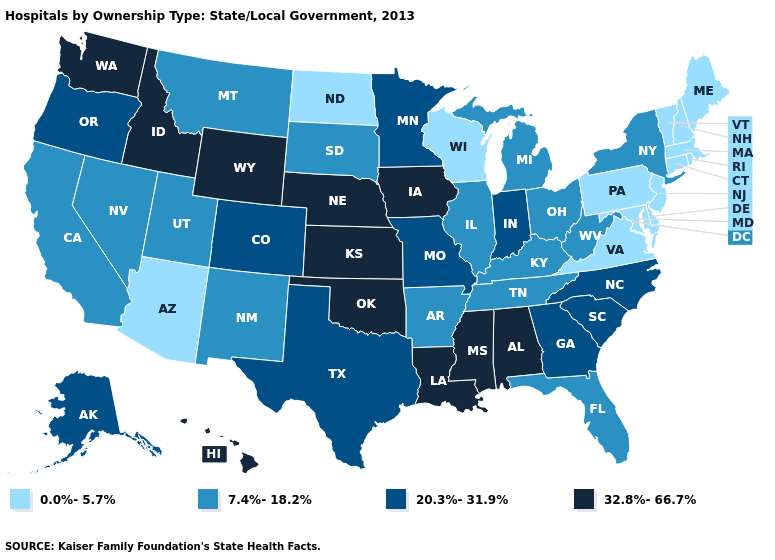What is the value of Connecticut?
Quick response, please. 0.0%-5.7%. Name the states that have a value in the range 7.4%-18.2%?
Write a very short answer. Arkansas, California, Florida, Illinois, Kentucky, Michigan, Montana, Nevada, New Mexico, New York, Ohio, South Dakota, Tennessee, Utah, West Virginia. Name the states that have a value in the range 20.3%-31.9%?
Answer briefly. Alaska, Colorado, Georgia, Indiana, Minnesota, Missouri, North Carolina, Oregon, South Carolina, Texas. Name the states that have a value in the range 0.0%-5.7%?
Short answer required. Arizona, Connecticut, Delaware, Maine, Maryland, Massachusetts, New Hampshire, New Jersey, North Dakota, Pennsylvania, Rhode Island, Vermont, Virginia, Wisconsin. Name the states that have a value in the range 32.8%-66.7%?
Quick response, please. Alabama, Hawaii, Idaho, Iowa, Kansas, Louisiana, Mississippi, Nebraska, Oklahoma, Washington, Wyoming. Name the states that have a value in the range 20.3%-31.9%?
Write a very short answer. Alaska, Colorado, Georgia, Indiana, Minnesota, Missouri, North Carolina, Oregon, South Carolina, Texas. What is the value of South Carolina?
Be succinct. 20.3%-31.9%. What is the value of New Jersey?
Be succinct. 0.0%-5.7%. What is the lowest value in states that border Indiana?
Short answer required. 7.4%-18.2%. Is the legend a continuous bar?
Short answer required. No. Which states have the highest value in the USA?
Keep it brief. Alabama, Hawaii, Idaho, Iowa, Kansas, Louisiana, Mississippi, Nebraska, Oklahoma, Washington, Wyoming. Is the legend a continuous bar?
Give a very brief answer. No. Among the states that border Vermont , does New York have the lowest value?
Write a very short answer. No. Is the legend a continuous bar?
Give a very brief answer. No. 